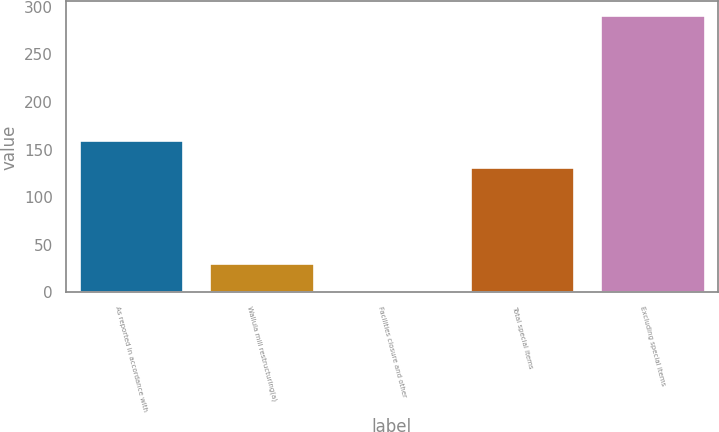Convert chart to OTSL. <chart><loc_0><loc_0><loc_500><loc_500><bar_chart><fcel>As reported in accordance with<fcel>Wallula mill restructuring(a)<fcel>Facilities closure and other<fcel>Total special items<fcel>Excluding special items<nl><fcel>160.2<fcel>31.2<fcel>2.3<fcel>131.3<fcel>291.3<nl></chart> 